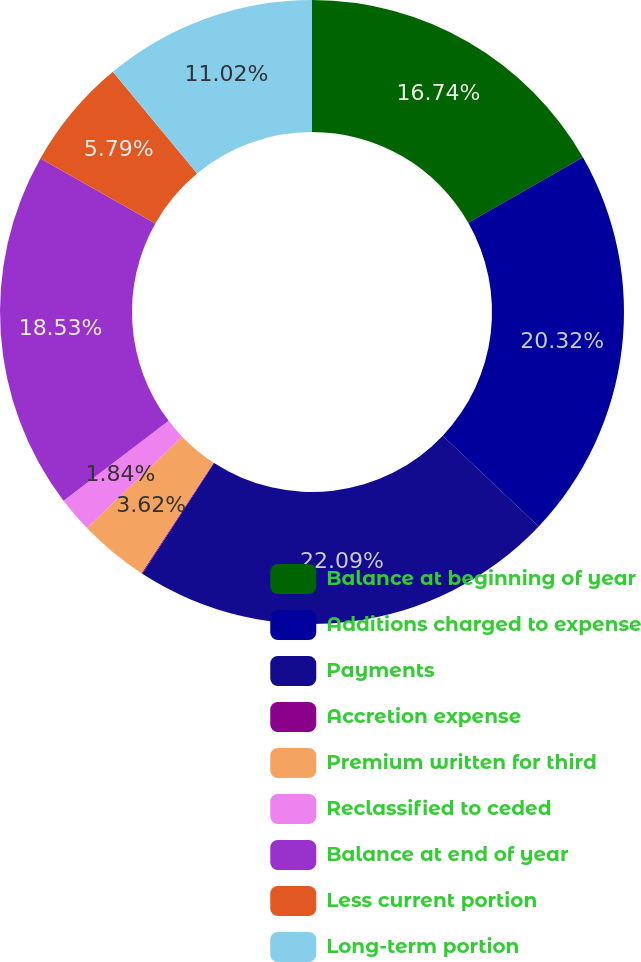Convert chart. <chart><loc_0><loc_0><loc_500><loc_500><pie_chart><fcel>Balance at beginning of year<fcel>Additions charged to expense<fcel>Payments<fcel>Accretion expense<fcel>Premium written for third<fcel>Reclassified to ceded<fcel>Balance at end of year<fcel>Less current portion<fcel>Long-term portion<nl><fcel>16.74%<fcel>20.32%<fcel>22.1%<fcel>0.05%<fcel>3.62%<fcel>1.84%<fcel>18.53%<fcel>5.79%<fcel>11.02%<nl></chart> 